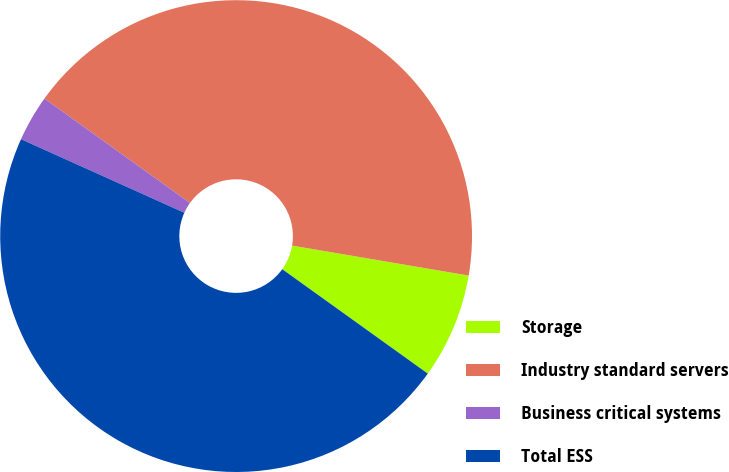<chart> <loc_0><loc_0><loc_500><loc_500><pie_chart><fcel>Storage<fcel>Industry standard servers<fcel>Business critical systems<fcel>Total ESS<nl><fcel>7.23%<fcel>42.77%<fcel>3.17%<fcel>46.83%<nl></chart> 